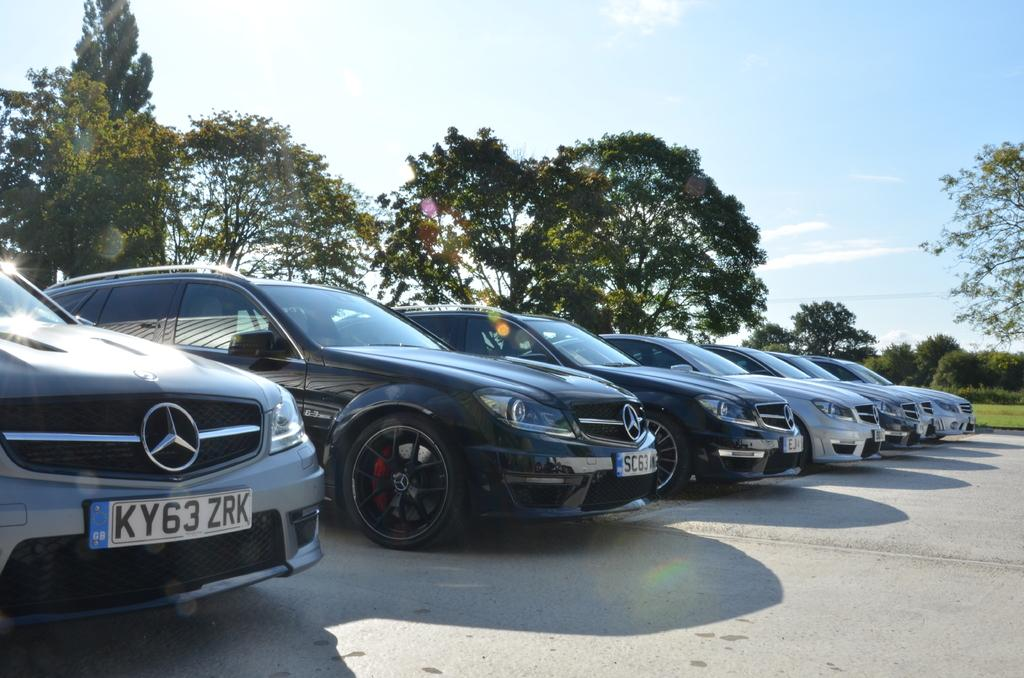What is the main subject in the center of the image? There are cars in the center of the image. What can be seen in the background of the image? There are trees in the background of the image. What type of vegetation is on the ground? There is grass on the ground. How would you describe the sky in the image? The sky is cloudy. Where is the boy playing with the basin in the image? There is no boy or basin present in the image. What type of party is happening in the image? There is no party depicted in the image. 